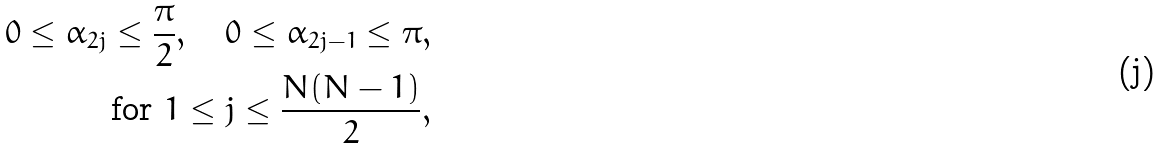Convert formula to latex. <formula><loc_0><loc_0><loc_500><loc_500>0 \leq \alpha _ { 2 j } \leq \frac { \pi } { 2 } , \quad 0 \leq \alpha _ { 2 j - 1 } \leq \pi , \\ \text { for } 1 \leq j \leq \frac { N ( N - 1 ) } { 2 } ,</formula> 